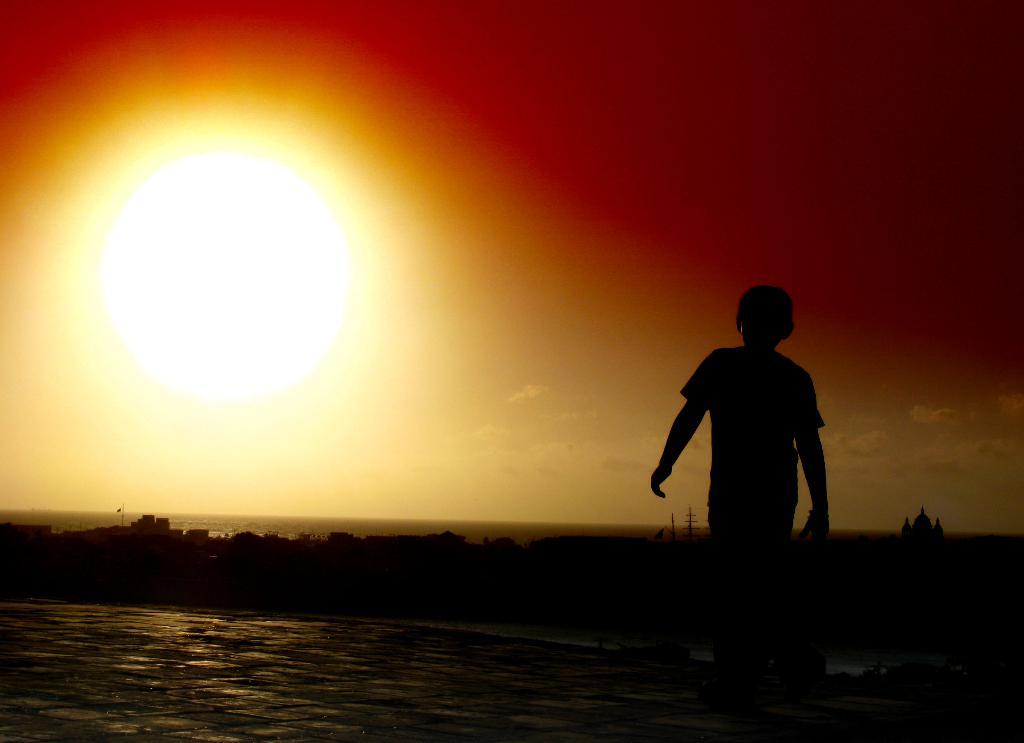What is the person on the right side of the image doing? There is a person walking on the ground on the right side of the image. What can be seen in the distance behind the person? There are buildings and trees in the background of the image. What is visible in the sky in the image? The sky is visible in the image, and there are clouds and the sun present. What game is the person playing in the image? There is no game being played in the image; the person is simply walking on the ground. 